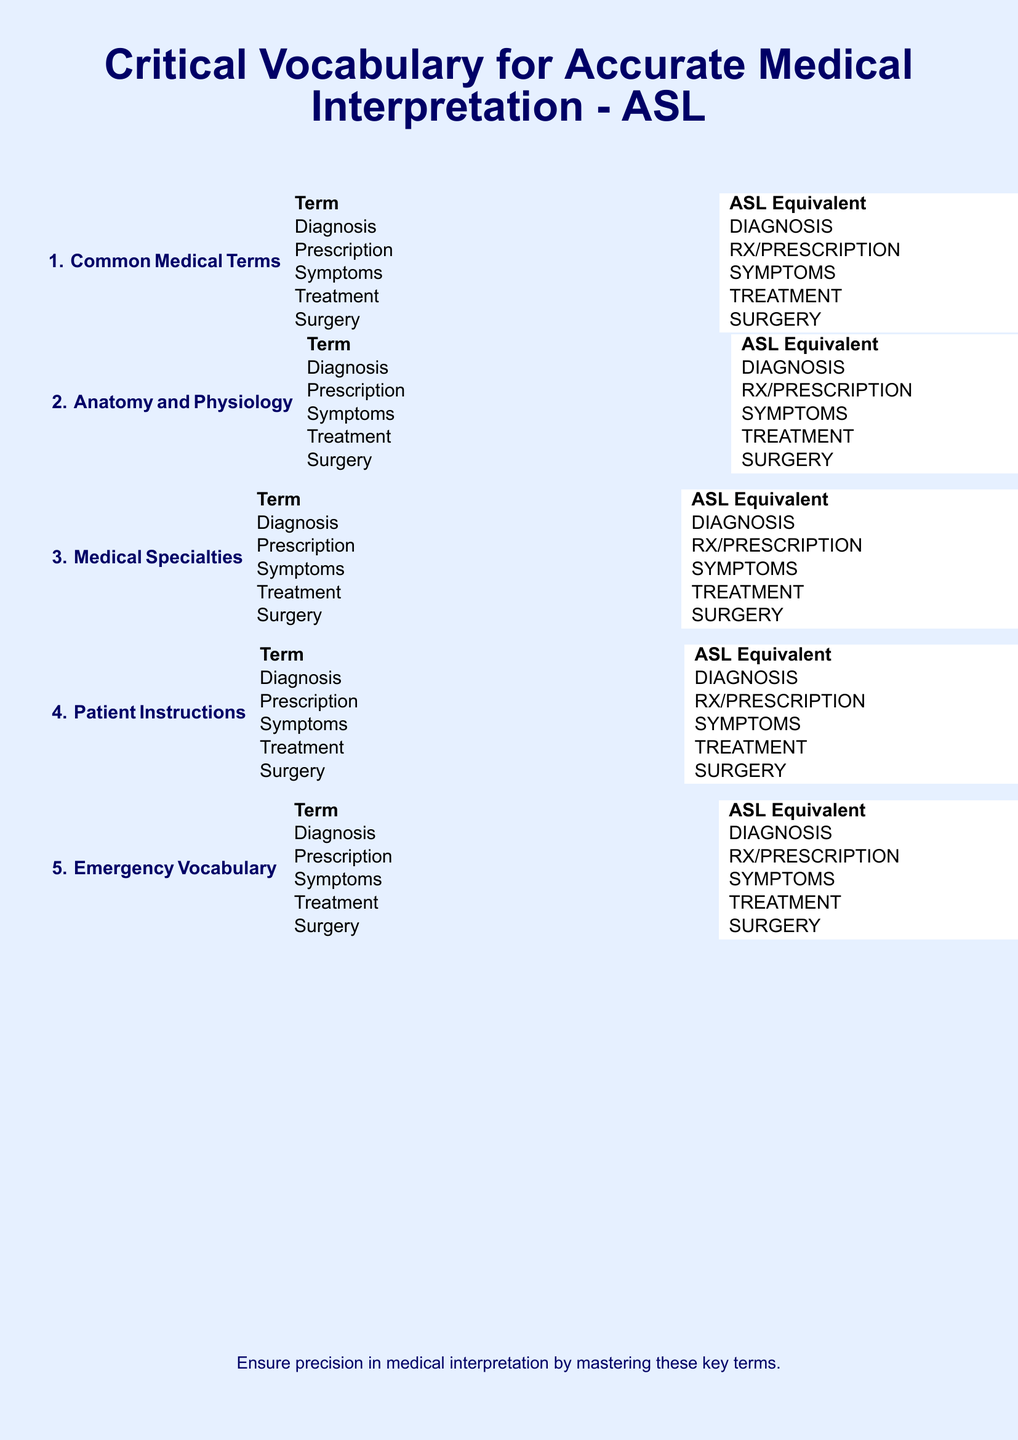What is the title of the document? The title of the document is prominently displayed at the top.
Answer: Critical Vocabulary for Accurate Medical Interpretation - ASL How many sections are listed in the document? The sections are numbered, and counting gives a total of five.
Answer: 5 What is the ASL equivalent for "Diagnosis"? The ASL equivalent can be found under the Common Medical Terms section.
Answer: DIAGNOSIS Which section would you find patient instructions? The structure of the document indicates sections, and patient instructions are specifically listed.
Answer: Patient Instructions What color is used for the background of the document? The background color is specified and noticeable at a glance.
Answer: light blue What is a common medical term related to treatment? The document lists various terms, and treatment is among them.
Answer: Treatment Name one medical specialty mentioned in the document. The document contains sections that outline different categories, including medical specialties.
Answer: (this term is not provided in the sample; hence this would be an example of iterative questioning) What does the document suggest for precision in medical interpretation? The document concludes with a recommendation regarding mastering terms for effectiveness.
Answer: Mastering these key terms 